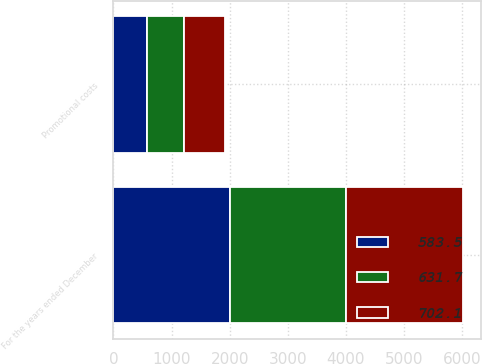<chart> <loc_0><loc_0><loc_500><loc_500><stacked_bar_chart><ecel><fcel>For the years ended December<fcel>Promotional costs<nl><fcel>702.1<fcel>2007<fcel>702.1<nl><fcel>631.7<fcel>2006<fcel>631.7<nl><fcel>583.5<fcel>2005<fcel>583.5<nl></chart> 